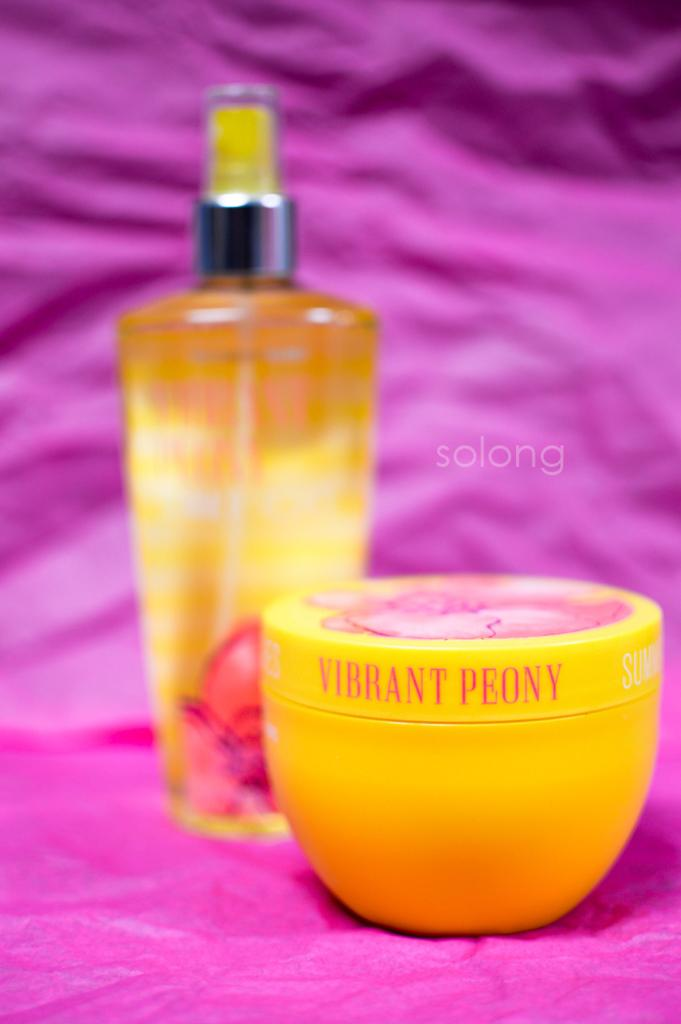What is the main subject of the image? The main subjects of the image are a perfume bottle and a cream box. What color are the perfume bottle and cream box? Both the perfume bottle and cream box are yellow. What is the color of the cloth on which the items are placed? The items are placed on a pink cloth. Is there any pink cloth visible in the background? Yes, there is a pink cloth visible in the background. What type of birds can be seen flying over the perfume bottle in the image? There are no birds visible in the image; it only features a perfume bottle, a cream box, and a pink cloth. 